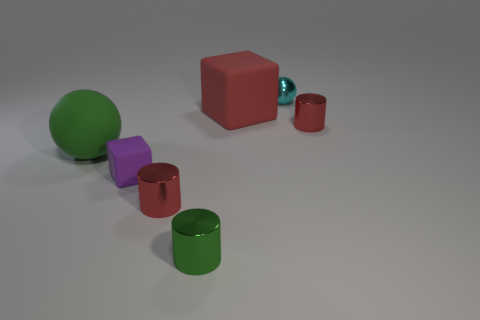Subtract all green metal cylinders. How many cylinders are left? 2 Add 1 cylinders. How many objects exist? 8 Add 2 tiny matte cubes. How many tiny matte cubes exist? 3 Subtract all green spheres. How many spheres are left? 1 Subtract 1 purple cubes. How many objects are left? 6 Subtract all balls. How many objects are left? 5 Subtract 2 cylinders. How many cylinders are left? 1 Subtract all purple spheres. Subtract all green blocks. How many spheres are left? 2 Subtract all gray cylinders. How many red cubes are left? 1 Subtract all cyan matte spheres. Subtract all big red matte objects. How many objects are left? 6 